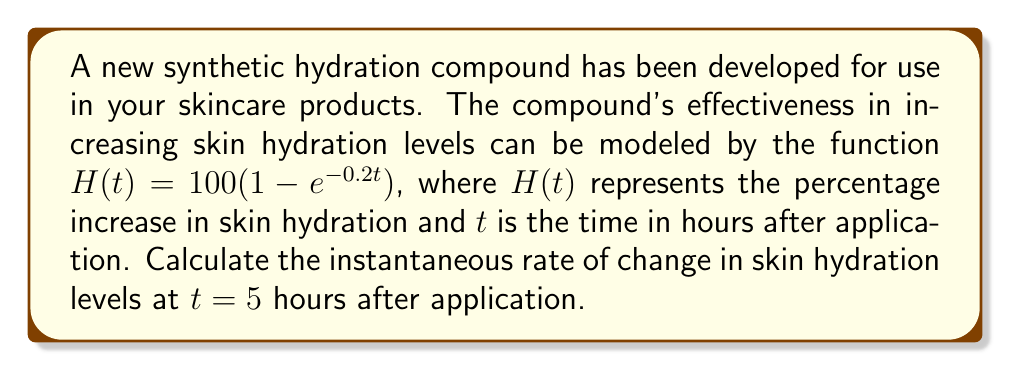Solve this math problem. To solve this problem, we need to find the derivative of the given function and evaluate it at $t = 5$. Here's the step-by-step process:

1) The given function is $H(t) = 100(1 - e^{-0.2t})$

2) To find the rate of change, we need to differentiate $H(t)$ with respect to $t$:

   $$\frac{d}{dt}H(t) = 100 \cdot \frac{d}{dt}(1 - e^{-0.2t})$$

3) Using the chain rule:

   $$\frac{d}{dt}H(t) = 100 \cdot (-1) \cdot (-0.2) \cdot e^{-0.2t}$$

4) Simplifying:

   $$\frac{d}{dt}H(t) = 20e^{-0.2t}$$

5) This derivative represents the instantaneous rate of change of hydration levels at any time $t$.

6) To find the rate of change at $t = 5$, we substitute $t = 5$ into our derivative:

   $$\frac{d}{dt}H(5) = 20e^{-0.2(5)} = 20e^{-1}$$

7) Calculating this value:

   $$20e^{-1} \approx 7.3576$$

Therefore, the instantaneous rate of change in skin hydration levels at $t = 5$ hours after application is approximately 7.3576% per hour.
Answer: $7.3576\%$ per hour 